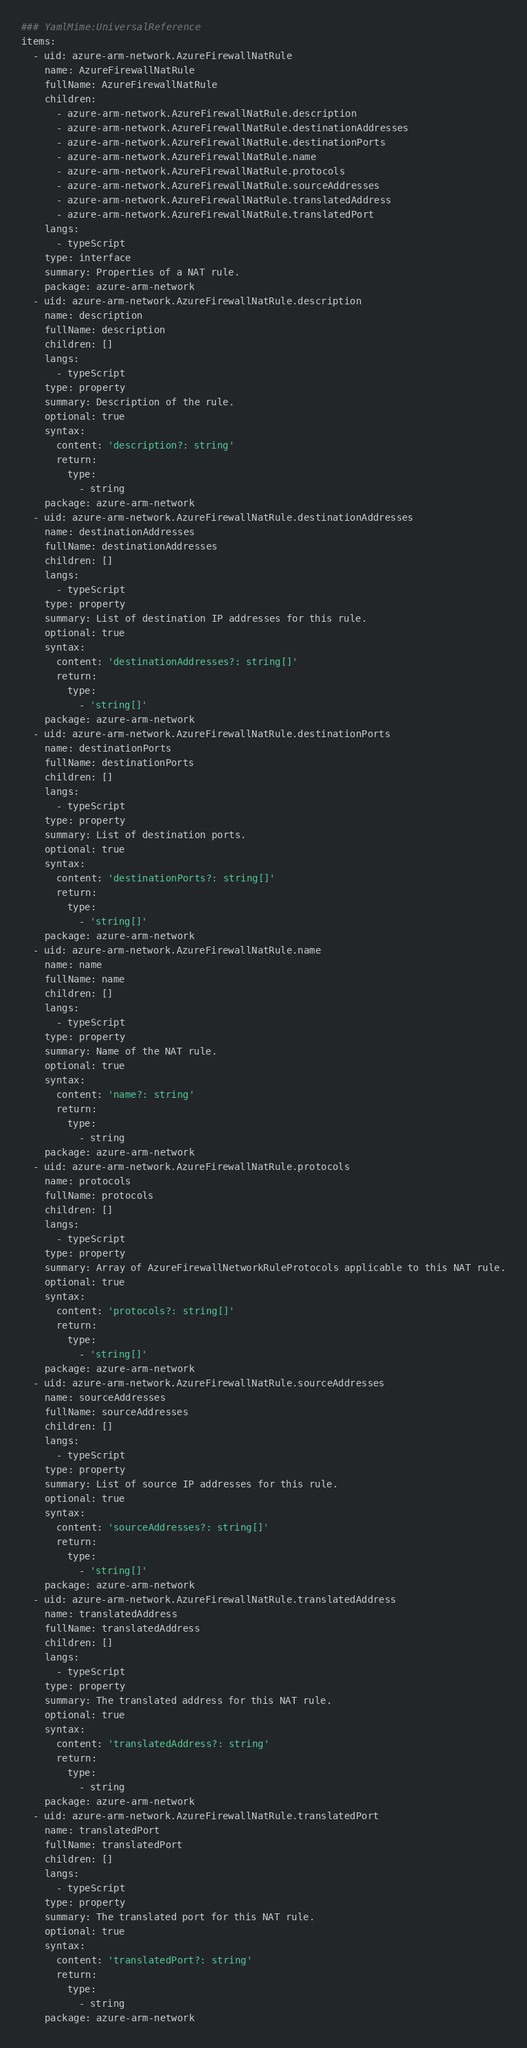<code> <loc_0><loc_0><loc_500><loc_500><_YAML_>### YamlMime:UniversalReference
items:
  - uid: azure-arm-network.AzureFirewallNatRule
    name: AzureFirewallNatRule
    fullName: AzureFirewallNatRule
    children:
      - azure-arm-network.AzureFirewallNatRule.description
      - azure-arm-network.AzureFirewallNatRule.destinationAddresses
      - azure-arm-network.AzureFirewallNatRule.destinationPorts
      - azure-arm-network.AzureFirewallNatRule.name
      - azure-arm-network.AzureFirewallNatRule.protocols
      - azure-arm-network.AzureFirewallNatRule.sourceAddresses
      - azure-arm-network.AzureFirewallNatRule.translatedAddress
      - azure-arm-network.AzureFirewallNatRule.translatedPort
    langs:
      - typeScript
    type: interface
    summary: Properties of a NAT rule.
    package: azure-arm-network
  - uid: azure-arm-network.AzureFirewallNatRule.description
    name: description
    fullName: description
    children: []
    langs:
      - typeScript
    type: property
    summary: Description of the rule.
    optional: true
    syntax:
      content: 'description?: string'
      return:
        type:
          - string
    package: azure-arm-network
  - uid: azure-arm-network.AzureFirewallNatRule.destinationAddresses
    name: destinationAddresses
    fullName: destinationAddresses
    children: []
    langs:
      - typeScript
    type: property
    summary: List of destination IP addresses for this rule.
    optional: true
    syntax:
      content: 'destinationAddresses?: string[]'
      return:
        type:
          - 'string[]'
    package: azure-arm-network
  - uid: azure-arm-network.AzureFirewallNatRule.destinationPorts
    name: destinationPorts
    fullName: destinationPorts
    children: []
    langs:
      - typeScript
    type: property
    summary: List of destination ports.
    optional: true
    syntax:
      content: 'destinationPorts?: string[]'
      return:
        type:
          - 'string[]'
    package: azure-arm-network
  - uid: azure-arm-network.AzureFirewallNatRule.name
    name: name
    fullName: name
    children: []
    langs:
      - typeScript
    type: property
    summary: Name of the NAT rule.
    optional: true
    syntax:
      content: 'name?: string'
      return:
        type:
          - string
    package: azure-arm-network
  - uid: azure-arm-network.AzureFirewallNatRule.protocols
    name: protocols
    fullName: protocols
    children: []
    langs:
      - typeScript
    type: property
    summary: Array of AzureFirewallNetworkRuleProtocols applicable to this NAT rule.
    optional: true
    syntax:
      content: 'protocols?: string[]'
      return:
        type:
          - 'string[]'
    package: azure-arm-network
  - uid: azure-arm-network.AzureFirewallNatRule.sourceAddresses
    name: sourceAddresses
    fullName: sourceAddresses
    children: []
    langs:
      - typeScript
    type: property
    summary: List of source IP addresses for this rule.
    optional: true
    syntax:
      content: 'sourceAddresses?: string[]'
      return:
        type:
          - 'string[]'
    package: azure-arm-network
  - uid: azure-arm-network.AzureFirewallNatRule.translatedAddress
    name: translatedAddress
    fullName: translatedAddress
    children: []
    langs:
      - typeScript
    type: property
    summary: The translated address for this NAT rule.
    optional: true
    syntax:
      content: 'translatedAddress?: string'
      return:
        type:
          - string
    package: azure-arm-network
  - uid: azure-arm-network.AzureFirewallNatRule.translatedPort
    name: translatedPort
    fullName: translatedPort
    children: []
    langs:
      - typeScript
    type: property
    summary: The translated port for this NAT rule.
    optional: true
    syntax:
      content: 'translatedPort?: string'
      return:
        type:
          - string
    package: azure-arm-network
</code> 